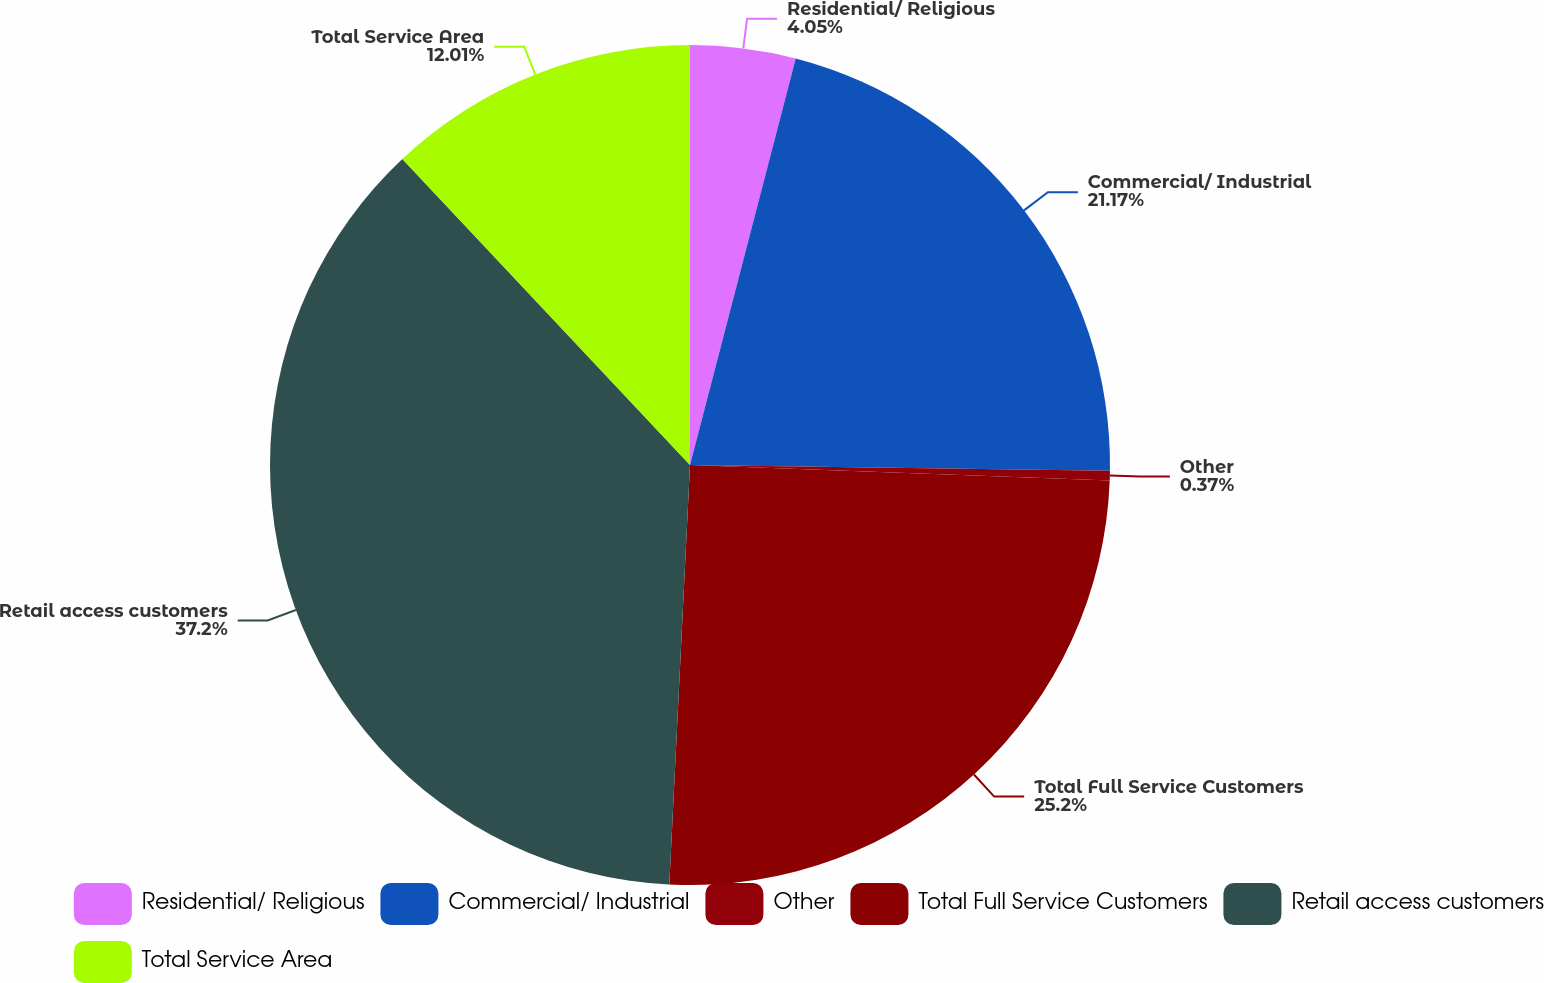Convert chart to OTSL. <chart><loc_0><loc_0><loc_500><loc_500><pie_chart><fcel>Residential/ Religious<fcel>Commercial/ Industrial<fcel>Other<fcel>Total Full Service Customers<fcel>Retail access customers<fcel>Total Service Area<nl><fcel>4.05%<fcel>21.17%<fcel>0.37%<fcel>25.2%<fcel>37.21%<fcel>12.01%<nl></chart> 